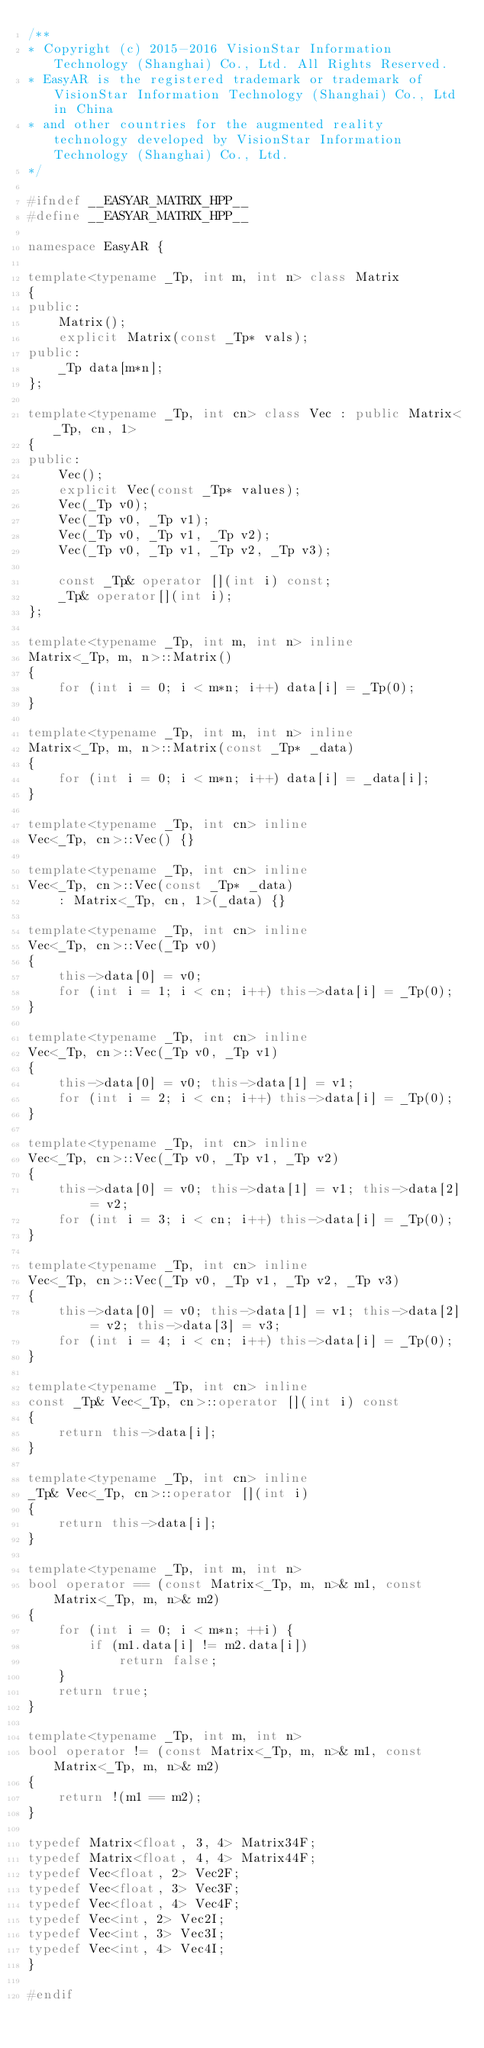<code> <loc_0><loc_0><loc_500><loc_500><_C++_>/**
* Copyright (c) 2015-2016 VisionStar Information Technology (Shanghai) Co., Ltd. All Rights Reserved.
* EasyAR is the registered trademark or trademark of VisionStar Information Technology (Shanghai) Co., Ltd in China
* and other countries for the augmented reality technology developed by VisionStar Information Technology (Shanghai) Co., Ltd.
*/

#ifndef __EASYAR_MATRIX_HPP__
#define __EASYAR_MATRIX_HPP__

namespace EasyAR {

template<typename _Tp, int m, int n> class Matrix
{
public:
    Matrix();
    explicit Matrix(const _Tp* vals);
public:
    _Tp data[m*n];
};

template<typename _Tp, int cn> class Vec : public Matrix<_Tp, cn, 1>
{
public:
    Vec();
    explicit Vec(const _Tp* values);
    Vec(_Tp v0);
    Vec(_Tp v0, _Tp v1);
    Vec(_Tp v0, _Tp v1, _Tp v2);
    Vec(_Tp v0, _Tp v1, _Tp v2, _Tp v3);

    const _Tp& operator [](int i) const;
    _Tp& operator[](int i);
};

template<typename _Tp, int m, int n> inline
Matrix<_Tp, m, n>::Matrix()
{
    for (int i = 0; i < m*n; i++) data[i] = _Tp(0);
}

template<typename _Tp, int m, int n> inline
Matrix<_Tp, m, n>::Matrix(const _Tp* _data)
{
    for (int i = 0; i < m*n; i++) data[i] = _data[i];
}

template<typename _Tp, int cn> inline
Vec<_Tp, cn>::Vec() {}

template<typename _Tp, int cn> inline
Vec<_Tp, cn>::Vec(const _Tp* _data)
    : Matrix<_Tp, cn, 1>(_data) {}

template<typename _Tp, int cn> inline
Vec<_Tp, cn>::Vec(_Tp v0)
{
    this->data[0] = v0;
    for (int i = 1; i < cn; i++) this->data[i] = _Tp(0);
}

template<typename _Tp, int cn> inline
Vec<_Tp, cn>::Vec(_Tp v0, _Tp v1)
{
    this->data[0] = v0; this->data[1] = v1;
    for (int i = 2; i < cn; i++) this->data[i] = _Tp(0);
}

template<typename _Tp, int cn> inline
Vec<_Tp, cn>::Vec(_Tp v0, _Tp v1, _Tp v2)
{
    this->data[0] = v0; this->data[1] = v1; this->data[2] = v2;
    for (int i = 3; i < cn; i++) this->data[i] = _Tp(0);
}

template<typename _Tp, int cn> inline
Vec<_Tp, cn>::Vec(_Tp v0, _Tp v1, _Tp v2, _Tp v3)
{
    this->data[0] = v0; this->data[1] = v1; this->data[2] = v2; this->data[3] = v3;
    for (int i = 4; i < cn; i++) this->data[i] = _Tp(0);
}

template<typename _Tp, int cn> inline
const _Tp& Vec<_Tp, cn>::operator [](int i) const
{
    return this->data[i];
}

template<typename _Tp, int cn> inline
_Tp& Vec<_Tp, cn>::operator [](int i)
{
    return this->data[i];
}

template<typename _Tp, int m, int n>
bool operator == (const Matrix<_Tp, m, n>& m1, const Matrix<_Tp, m, n>& m2)
{
    for (int i = 0; i < m*n; ++i) {
        if (m1.data[i] != m2.data[i])
            return false;
    }
    return true;
}

template<typename _Tp, int m, int n>
bool operator != (const Matrix<_Tp, m, n>& m1, const Matrix<_Tp, m, n>& m2)
{
    return !(m1 == m2);
}

typedef Matrix<float, 3, 4> Matrix34F;
typedef Matrix<float, 4, 4> Matrix44F;
typedef Vec<float, 2> Vec2F;
typedef Vec<float, 3> Vec3F;
typedef Vec<float, 4> Vec4F;
typedef Vec<int, 2> Vec2I;
typedef Vec<int, 3> Vec3I;
typedef Vec<int, 4> Vec4I;
}

#endif
</code> 